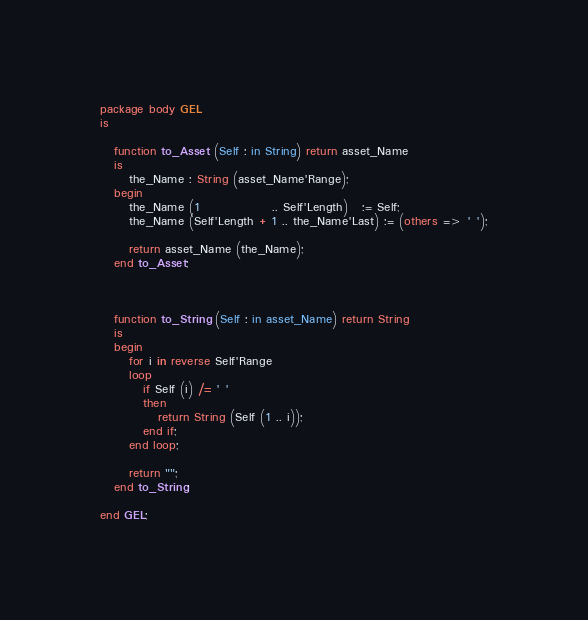<code> <loc_0><loc_0><loc_500><loc_500><_Ada_>package body GEL
is

   function to_Asset (Self : in String) return asset_Name
   is
      the_Name : String (asset_Name'Range);
   begin
      the_Name (1               .. Self'Length)   := Self;
      the_Name (Self'Length + 1 .. the_Name'Last) := (others => ' ');

      return asset_Name (the_Name);
   end to_Asset;



   function to_String (Self : in asset_Name) return String
   is
   begin
      for i in reverse Self'Range
      loop
         if Self (i) /= ' '
         then
            return String (Self (1 .. i));
         end if;
      end loop;

      return "";
   end to_String;

end GEL;
</code> 